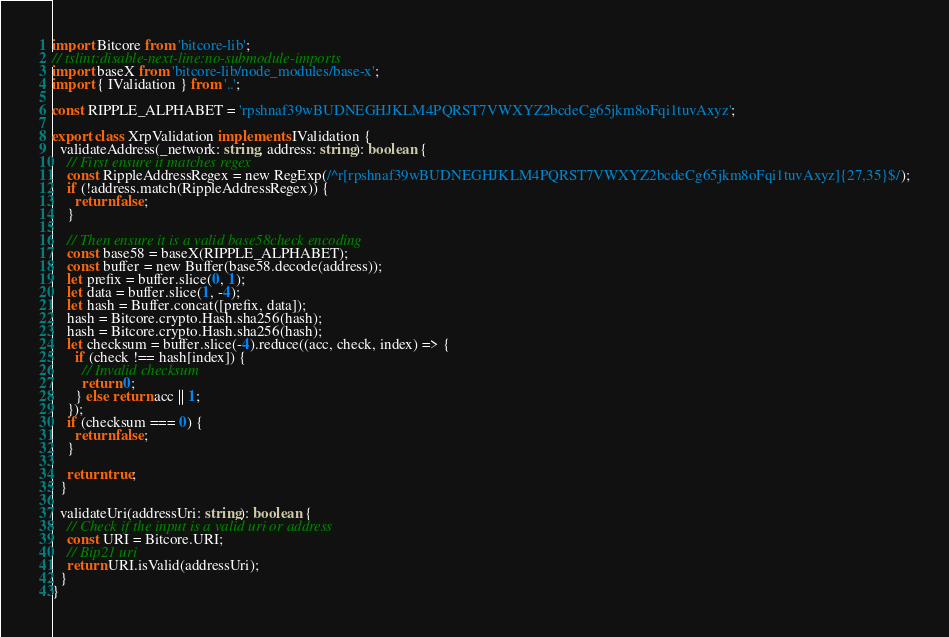<code> <loc_0><loc_0><loc_500><loc_500><_TypeScript_>import Bitcore from 'bitcore-lib';
// tslint:disable-next-line:no-submodule-imports
import baseX from 'bitcore-lib/node_modules/base-x';
import { IValidation } from '..';

const RIPPLE_ALPHABET = 'rpshnaf39wBUDNEGHJKLM4PQRST7VWXYZ2bcdeCg65jkm8oFqi1tuvAxyz';

export class XrpValidation implements IValidation {
  validateAddress(_network: string, address: string): boolean {
    // First ensure it matches regex
    const RippleAddressRegex = new RegExp(/^r[rpshnaf39wBUDNEGHJKLM4PQRST7VWXYZ2bcdeCg65jkm8oFqi1tuvAxyz]{27,35}$/);
    if (!address.match(RippleAddressRegex)) {
      return false;
    }

    // Then ensure it is a valid base58check encoding
    const base58 = baseX(RIPPLE_ALPHABET);
    const buffer = new Buffer(base58.decode(address));
    let prefix = buffer.slice(0, 1);
    let data = buffer.slice(1, -4);
    let hash = Buffer.concat([prefix, data]);
    hash = Bitcore.crypto.Hash.sha256(hash);
    hash = Bitcore.crypto.Hash.sha256(hash);
    let checksum = buffer.slice(-4).reduce((acc, check, index) => {
      if (check !== hash[index]) {
        // Invalid checksum
        return 0;
      } else return acc || 1;
    });
    if (checksum === 0) {
      return false;
    }

    return true;
  }

  validateUri(addressUri: string): boolean {
    // Check if the input is a valid uri or address
    const URI = Bitcore.URI;
    // Bip21 uri
    return URI.isValid(addressUri);
  }
}
</code> 